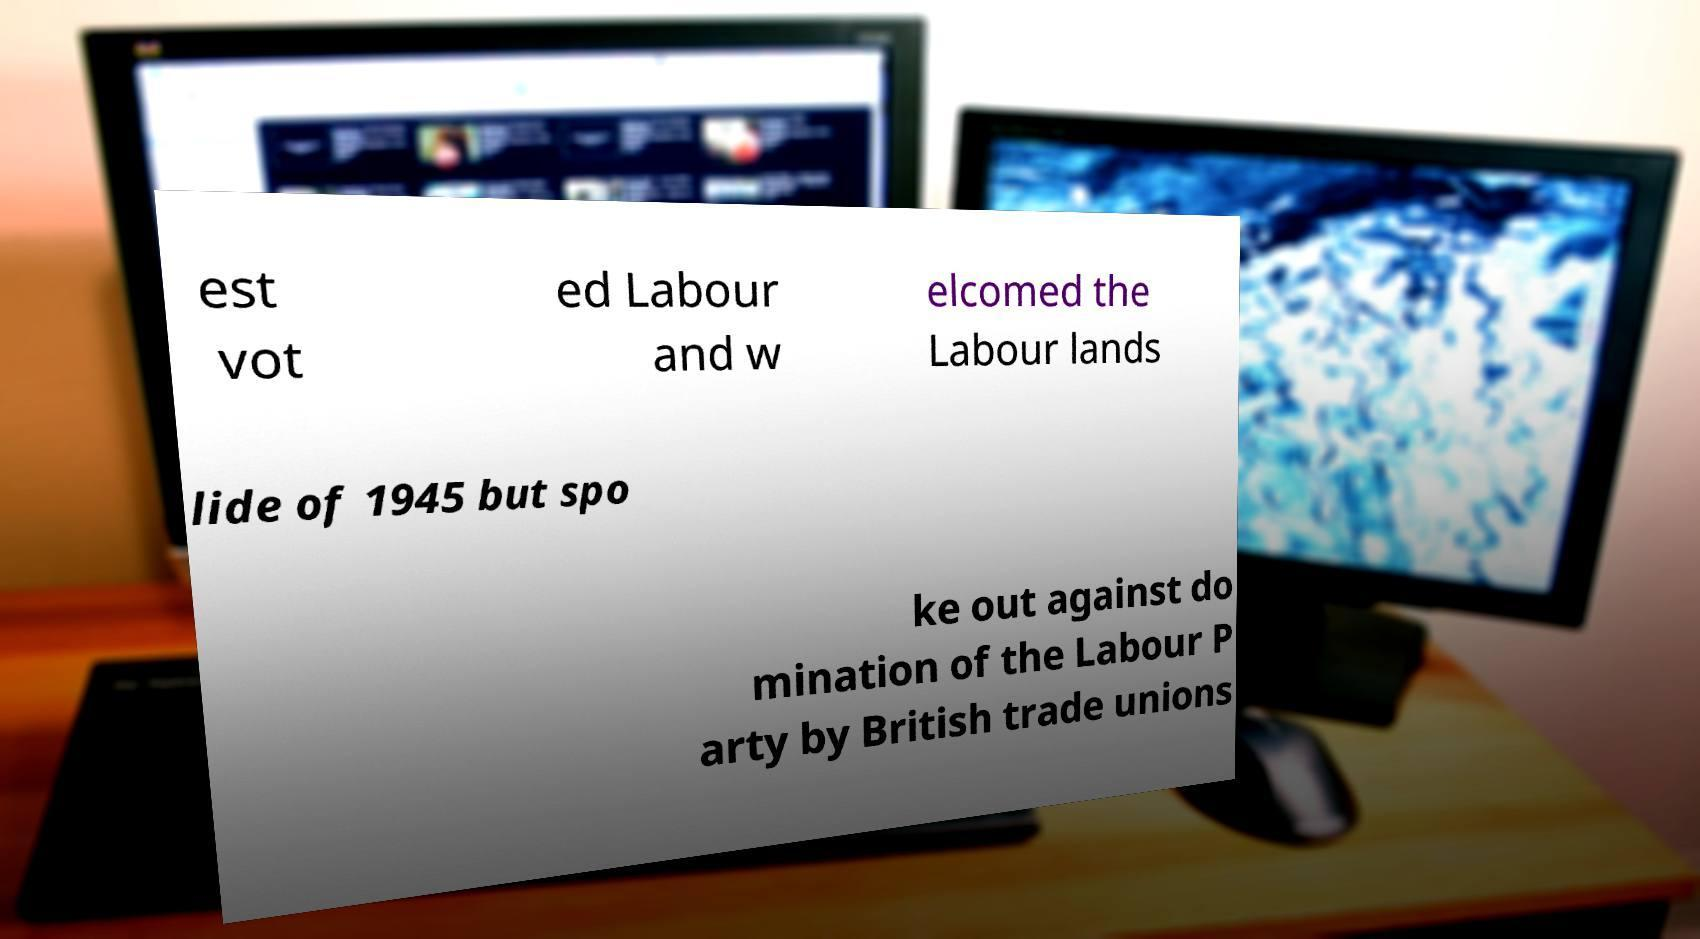Could you assist in decoding the text presented in this image and type it out clearly? est vot ed Labour and w elcomed the Labour lands lide of 1945 but spo ke out against do mination of the Labour P arty by British trade unions 